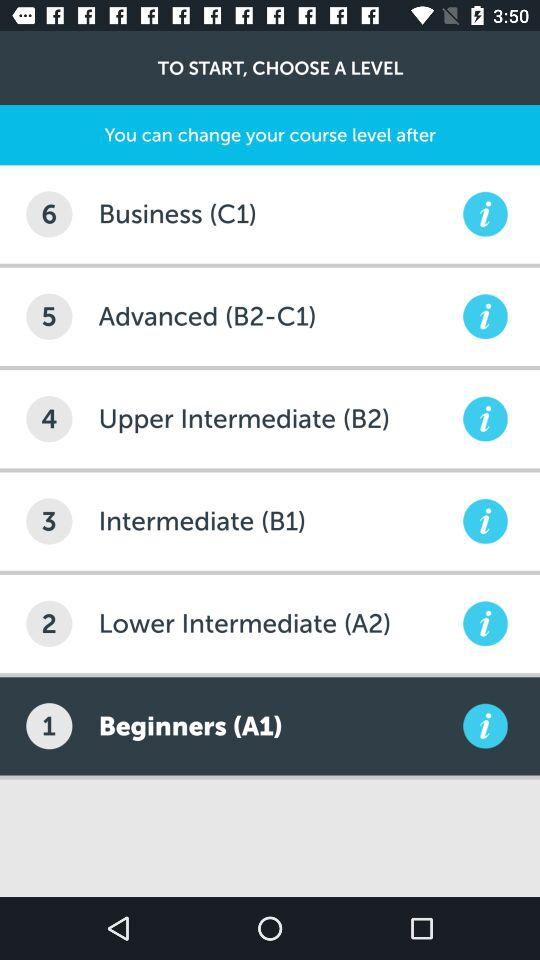What should be done to start? To start, a level should be chosen. 